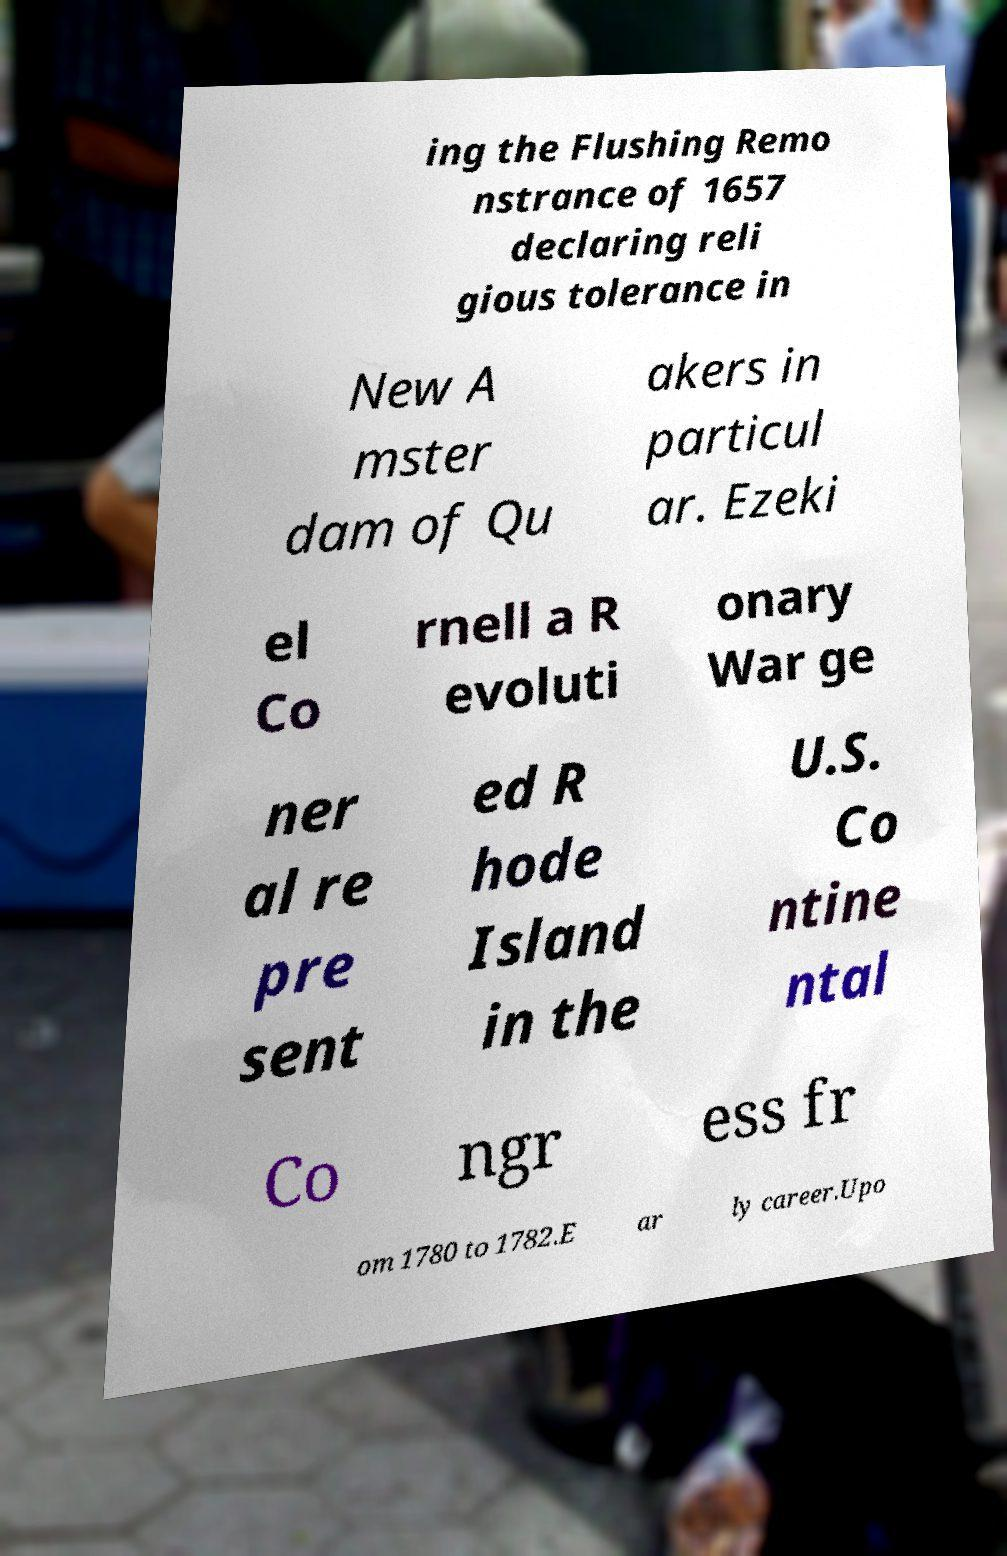Please read and relay the text visible in this image. What does it say? ing the Flushing Remo nstrance of 1657 declaring reli gious tolerance in New A mster dam of Qu akers in particul ar. Ezeki el Co rnell a R evoluti onary War ge ner al re pre sent ed R hode Island in the U.S. Co ntine ntal Co ngr ess fr om 1780 to 1782.E ar ly career.Upo 